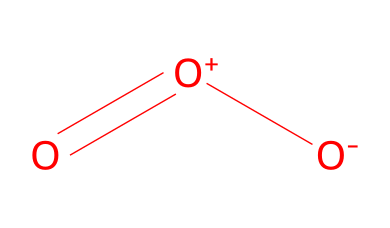What is the molecular composition of the chemical? The SMILES representation O=[O+][O-] indicates that the compound consists of three oxygen atoms, as each "O" represents one oxygen atom. The arrangement suggests the presence of a molecule known as ozone.
Answer: three oxygen atoms How many total atoms are in this molecule? In the SMILES notation, there are three "O" atoms, indicating that the total number of atoms in the molecule is three.
Answer: three What is the charge of the central atom in this molecule? The notation shows a positive charge on the first oxygen atom (O+), indicating that this atom carries a positive charge.
Answer: positive Is this molecule classified as a gas? Ozone is commonly known as a gas at room temperature and pressure, which aligns with the properties of this molecule representation.
Answer: yes What type of bonding is primarily present in ozone? The structure indicates a combination of double bonds, reflected in the notation with the "=" sign, which indicates that part of the bonding involves a double bond.
Answer: double bond How do ozone levels impact human health during outdoor activities like tennis? Increased levels of ozone can lead to respiratory issues and exacerbate conditions like asthma, which can have significant effects on athletes engaged in activities like tennis.
Answer: respiratory issues Can this molecule act as an oxidizing agent? Ozone is known for its strong oxidizing properties, meaning it can react with other substances to cause oxidation, which is indicated by its molecular structure.
Answer: yes 